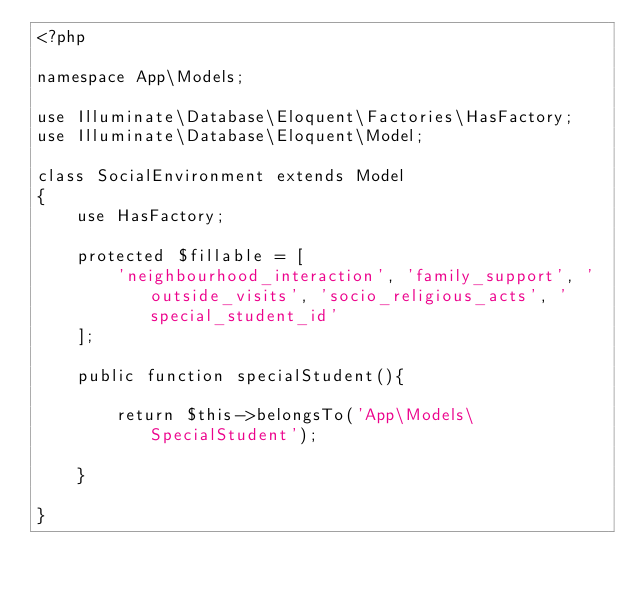<code> <loc_0><loc_0><loc_500><loc_500><_PHP_><?php

namespace App\Models;

use Illuminate\Database\Eloquent\Factories\HasFactory;
use Illuminate\Database\Eloquent\Model;

class SocialEnvironment extends Model
{
    use HasFactory;

    protected $fillable = [
        'neighbourhood_interaction', 'family_support', 'outside_visits', 'socio_religious_acts', 'special_student_id'
    ];

    public function specialStudent(){

        return $this->belongsTo('App\Models\SpecialStudent');
    
    }

}
</code> 